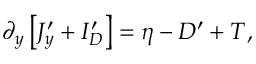Convert formula to latex. <formula><loc_0><loc_0><loc_500><loc_500>\partial _ { y } \left [ J _ { y } ^ { \prime } + I _ { D } ^ { \prime } \right ] = \eta - D ^ { \prime } + T ,</formula> 